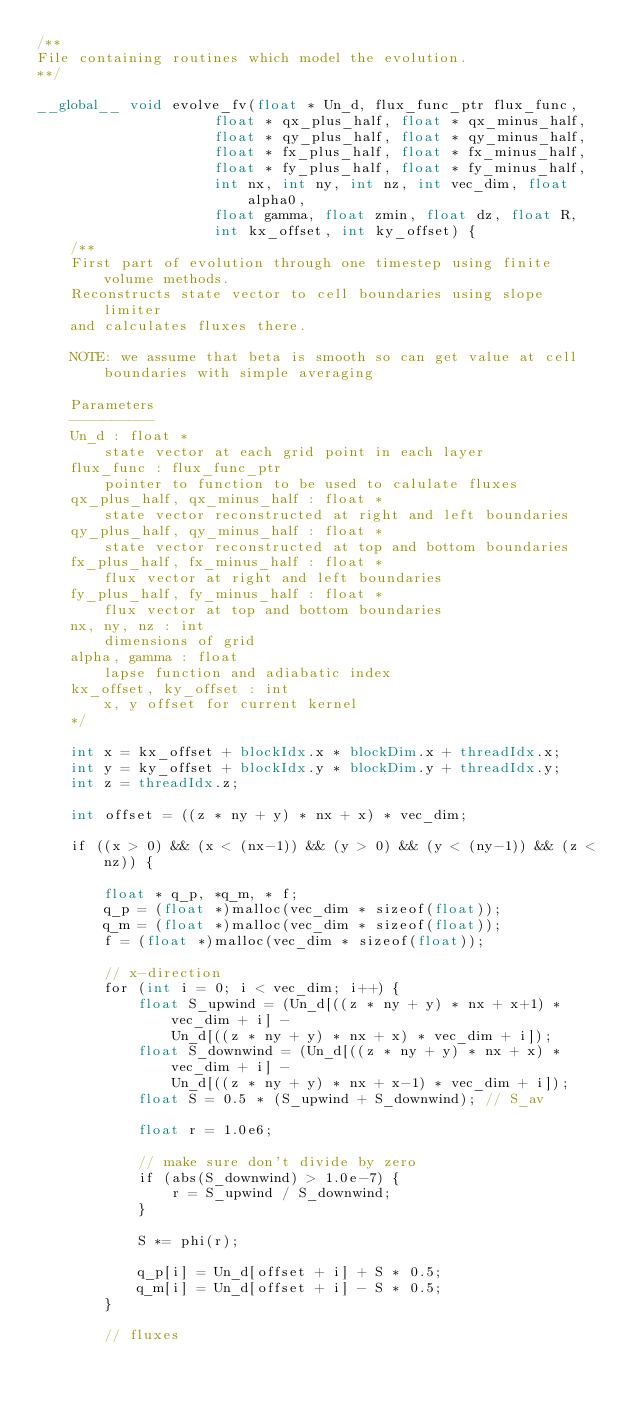Convert code to text. <code><loc_0><loc_0><loc_500><loc_500><_Cuda_>/**
File containing routines which model the evolution.
**/

__global__ void evolve_fv(float * Un_d, flux_func_ptr flux_func,
                     float * qx_plus_half, float * qx_minus_half,
                     float * qy_plus_half, float * qy_minus_half,
                     float * fx_plus_half, float * fx_minus_half,
                     float * fy_plus_half, float * fy_minus_half,
                     int nx, int ny, int nz, int vec_dim, float alpha0,
                     float gamma, float zmin, float dz, float R,
                     int kx_offset, int ky_offset) {
    /**
    First part of evolution through one timestep using finite volume methods.
    Reconstructs state vector to cell boundaries using slope limiter
    and calculates fluxes there.

    NOTE: we assume that beta is smooth so can get value at cell boundaries with simple averaging

    Parameters
    ----------
    Un_d : float *
        state vector at each grid point in each layer
    flux_func : flux_func_ptr
        pointer to function to be used to calulate fluxes
    qx_plus_half, qx_minus_half : float *
        state vector reconstructed at right and left boundaries
    qy_plus_half, qy_minus_half : float *
        state vector reconstructed at top and bottom boundaries
    fx_plus_half, fx_minus_half : float *
        flux vector at right and left boundaries
    fy_plus_half, fy_minus_half : float *
        flux vector at top and bottom boundaries
    nx, ny, nz : int
        dimensions of grid
    alpha, gamma : float
        lapse function and adiabatic index
    kx_offset, ky_offset : int
        x, y offset for current kernel
    */

    int x = kx_offset + blockIdx.x * blockDim.x + threadIdx.x;
    int y = ky_offset + blockIdx.y * blockDim.y + threadIdx.y;
    int z = threadIdx.z;

    int offset = ((z * ny + y) * nx + x) * vec_dim;

    if ((x > 0) && (x < (nx-1)) && (y > 0) && (y < (ny-1)) && (z < nz)) {

        float * q_p, *q_m, * f;
        q_p = (float *)malloc(vec_dim * sizeof(float));
        q_m = (float *)malloc(vec_dim * sizeof(float));
        f = (float *)malloc(vec_dim * sizeof(float));

        // x-direction
        for (int i = 0; i < vec_dim; i++) {
            float S_upwind = (Un_d[((z * ny + y) * nx + x+1) * vec_dim + i] -
                Un_d[((z * ny + y) * nx + x) * vec_dim + i]);
            float S_downwind = (Un_d[((z * ny + y) * nx + x) * vec_dim + i] -
                Un_d[((z * ny + y) * nx + x-1) * vec_dim + i]);
            float S = 0.5 * (S_upwind + S_downwind); // S_av

            float r = 1.0e6;

            // make sure don't divide by zero
            if (abs(S_downwind) > 1.0e-7) {
                r = S_upwind / S_downwind;
            }

            S *= phi(r);

            q_p[i] = Un_d[offset + i] + S * 0.5;
            q_m[i] = Un_d[offset + i] - S * 0.5;
        }

        // fluxes</code> 